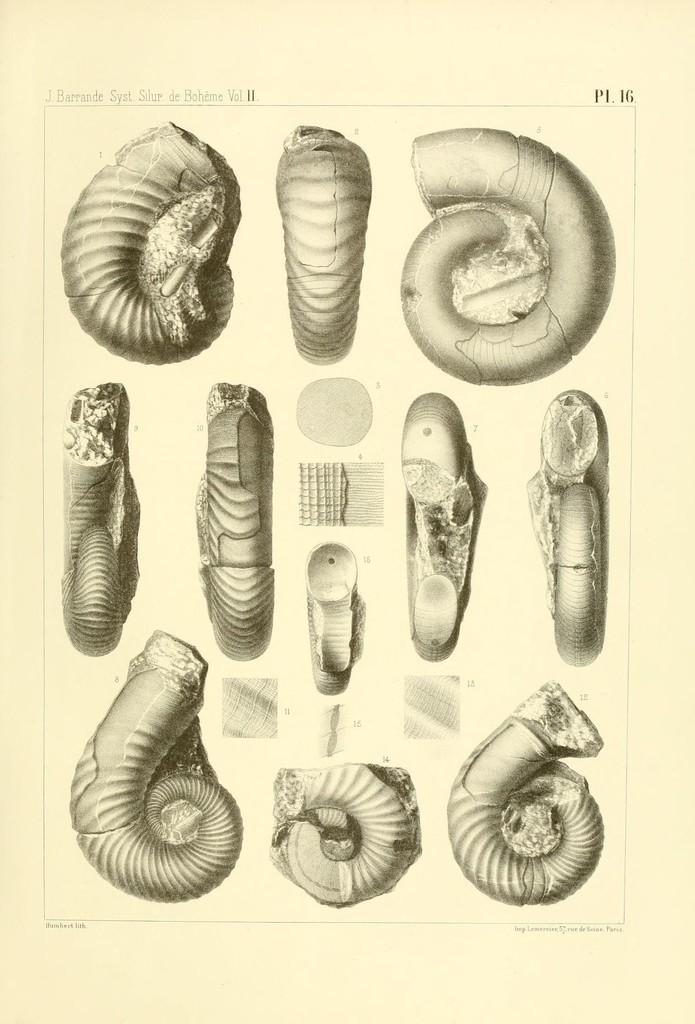What is the main object in the image? There is a paper in the image. What can be seen on the paper? The paper contains images of shells. What type of bottle is being used to cry in the image? There is no bottle or crying depicted in the image; it only features a paper with images of shells. 